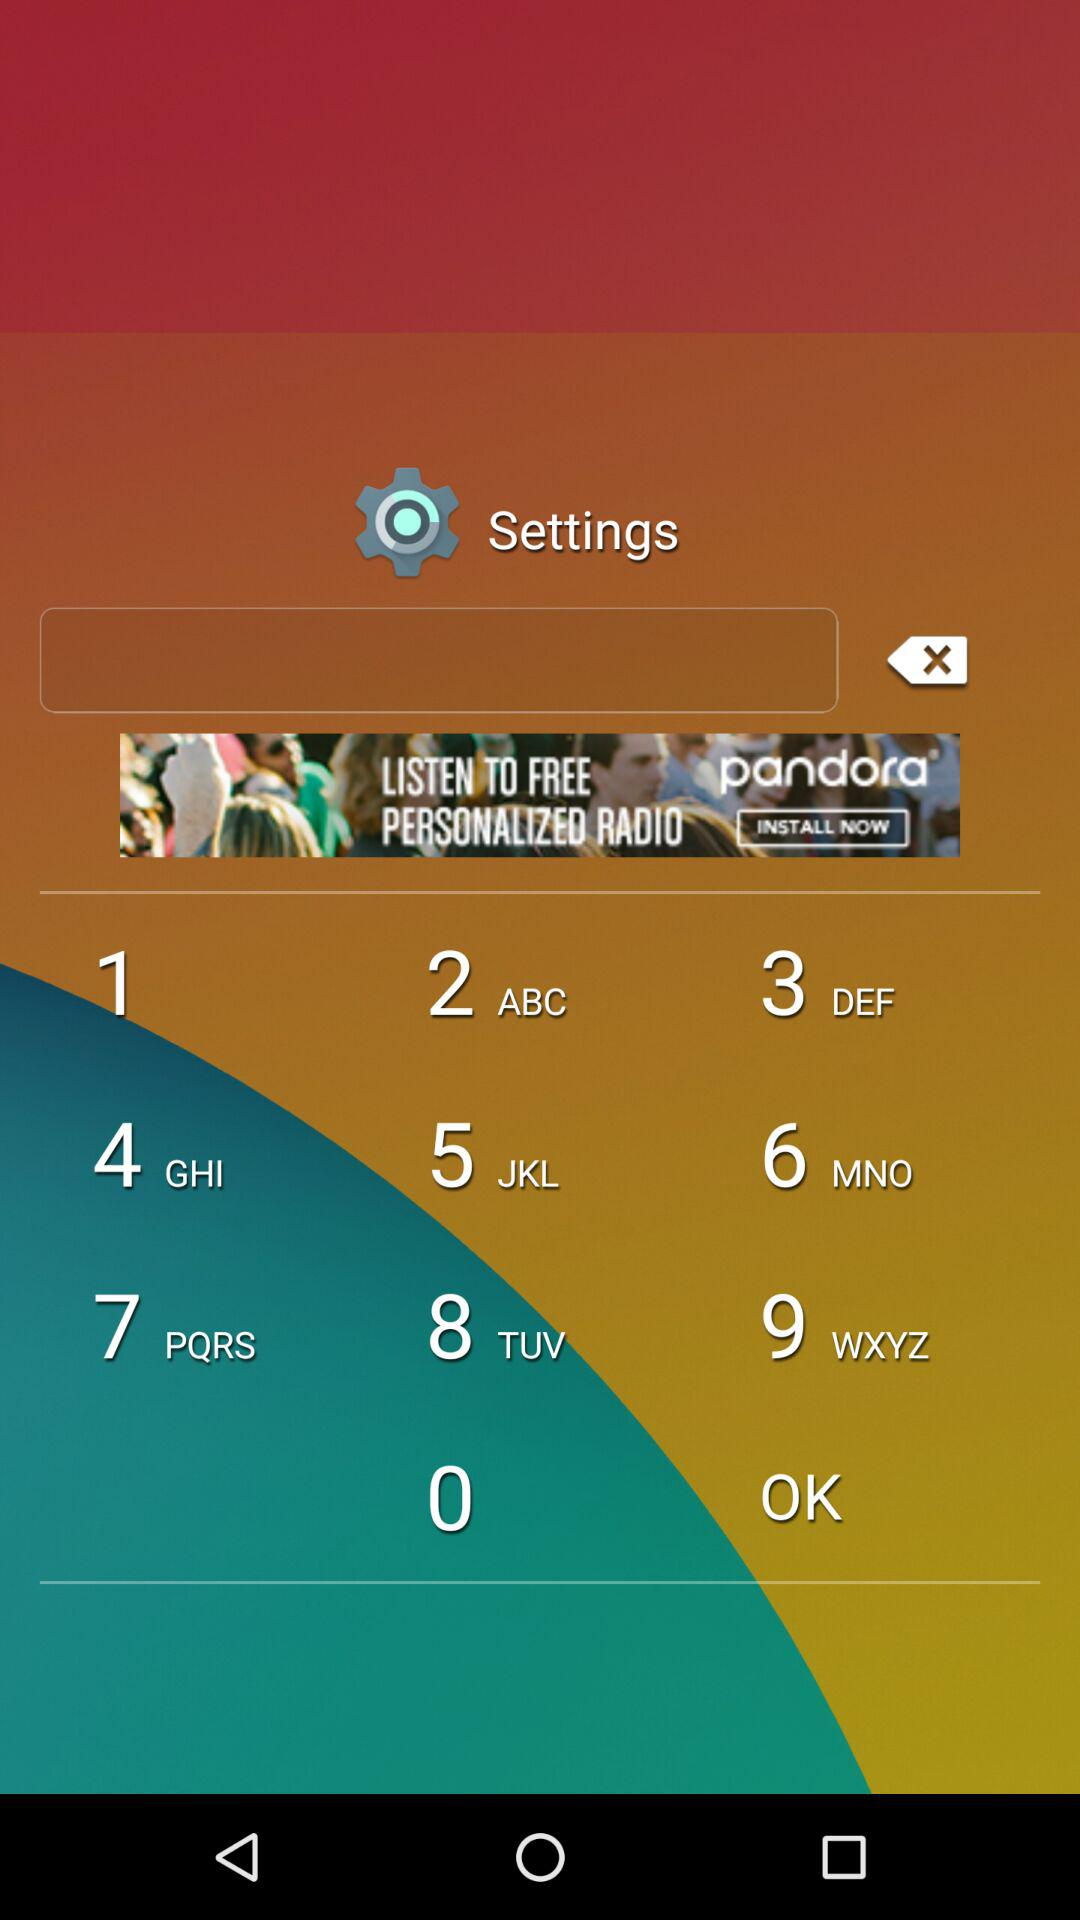Which tests are going on currently under quick check? The tests are "Blood pressure", "Oxygen", "Heart rate" and "Psychological". 